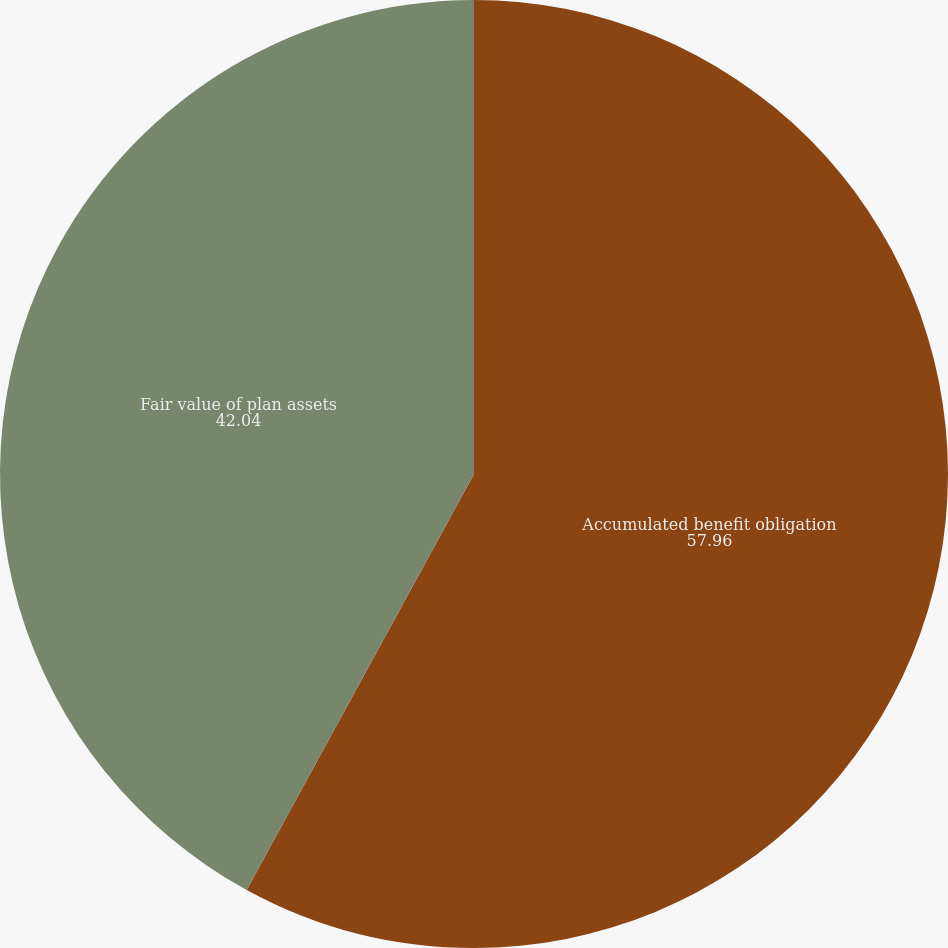Convert chart to OTSL. <chart><loc_0><loc_0><loc_500><loc_500><pie_chart><fcel>Accumulated benefit obligation<fcel>Fair value of plan assets<nl><fcel>57.96%<fcel>42.04%<nl></chart> 